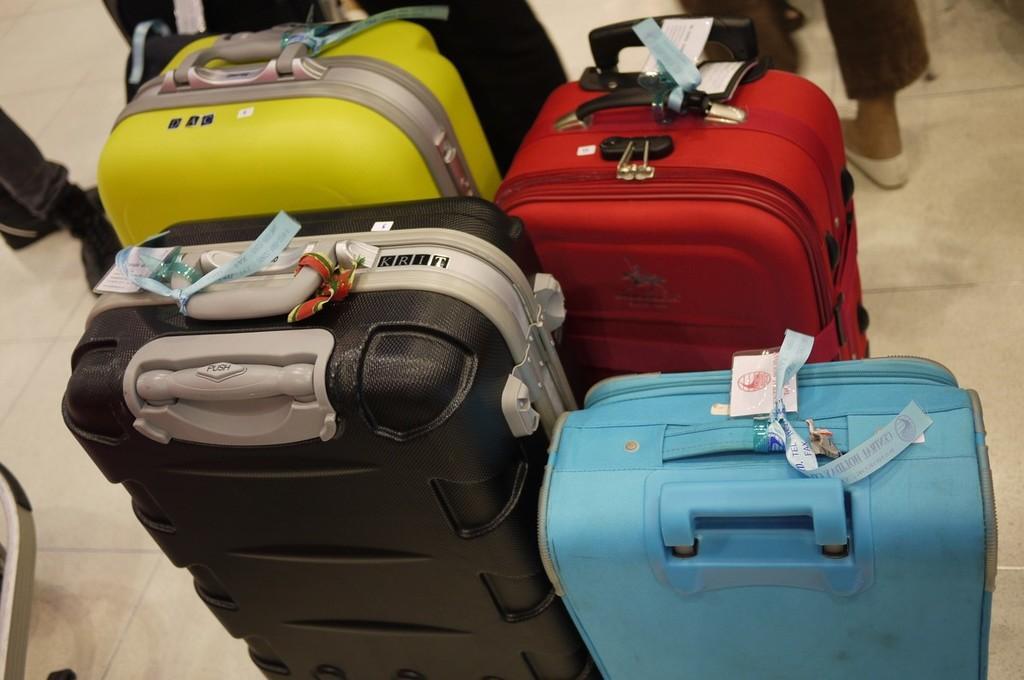Can you describe this image briefly? In this picture we can see four colors of suitcases with tags to it and this are placed on a floor where we can see some persons legs. 